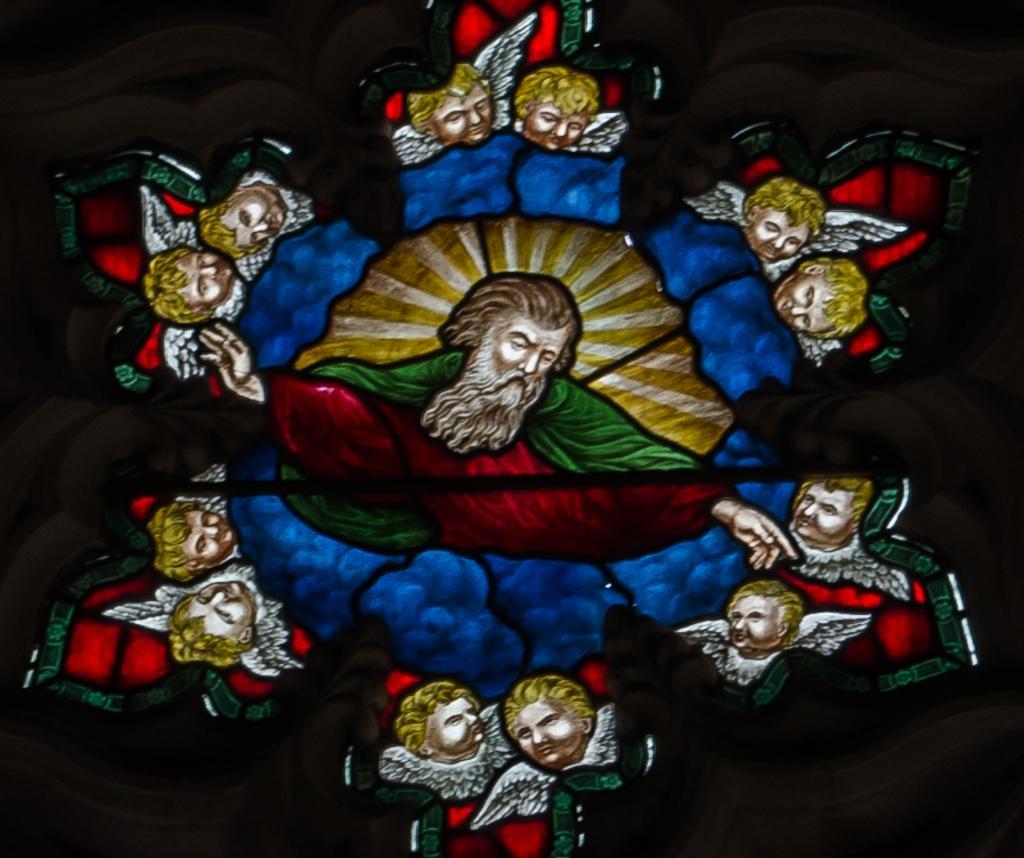How would you summarize this image in a sentence or two? The picture is looking like a frame or a painting over a window. In this picture we can see people's faces with wings. The edges are dark. 